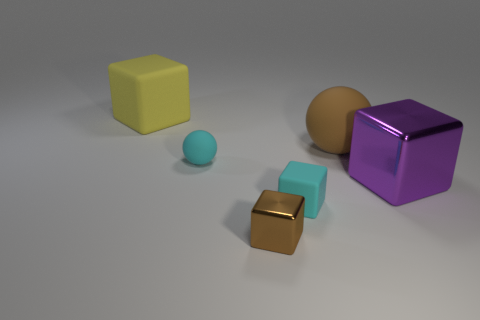Subtract all red blocks. Subtract all brown cylinders. How many blocks are left? 4 Add 2 large objects. How many objects exist? 8 Subtract all blocks. How many objects are left? 2 Add 3 tiny cyan blocks. How many tiny cyan blocks are left? 4 Add 4 large brown rubber things. How many large brown rubber things exist? 5 Subtract 1 cyan spheres. How many objects are left? 5 Subtract all large cyan objects. Subtract all cyan rubber objects. How many objects are left? 4 